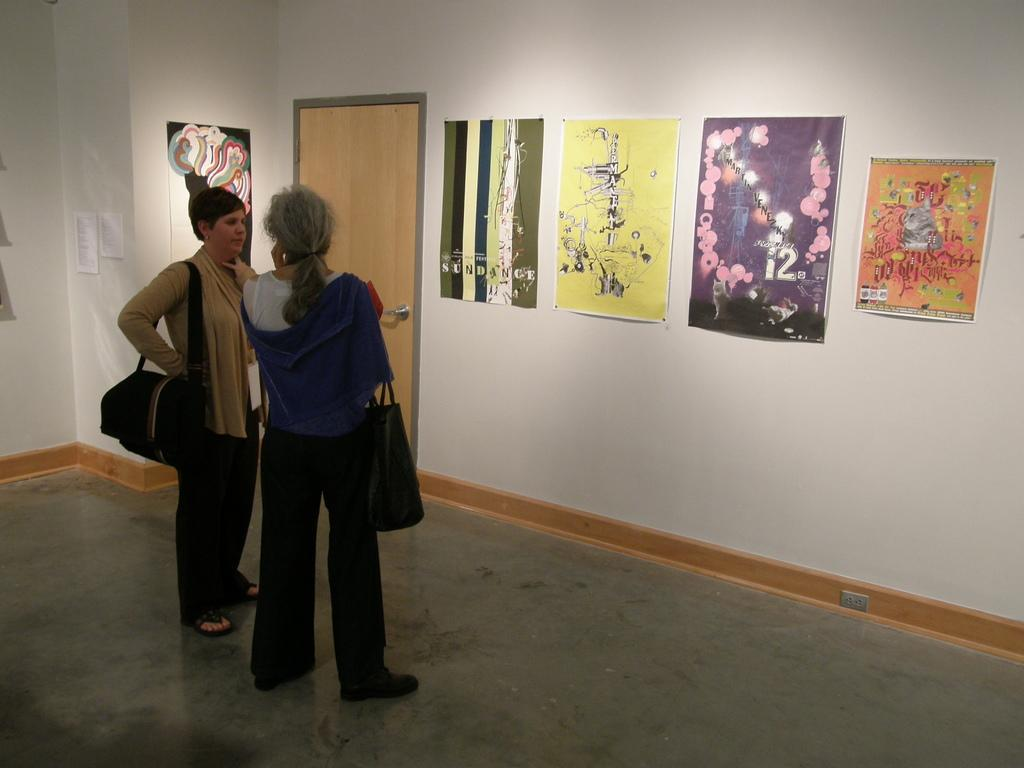How many people are in the image? There are two people in the image. What are the people doing in the image? The people are standing. What are the people wearing that might be used for carrying items? The people are wearing handbags. What can be seen in front of the people? There are posters in front of the people. What architectural feature is visible in the image? There is a door in the image, and it is part of a wall. What is the daily profit of the carpenter in the image? There is no carpenter or mention of profit in the image. The image features two people standing with posters in front of them, and a door that is part of a wall. 